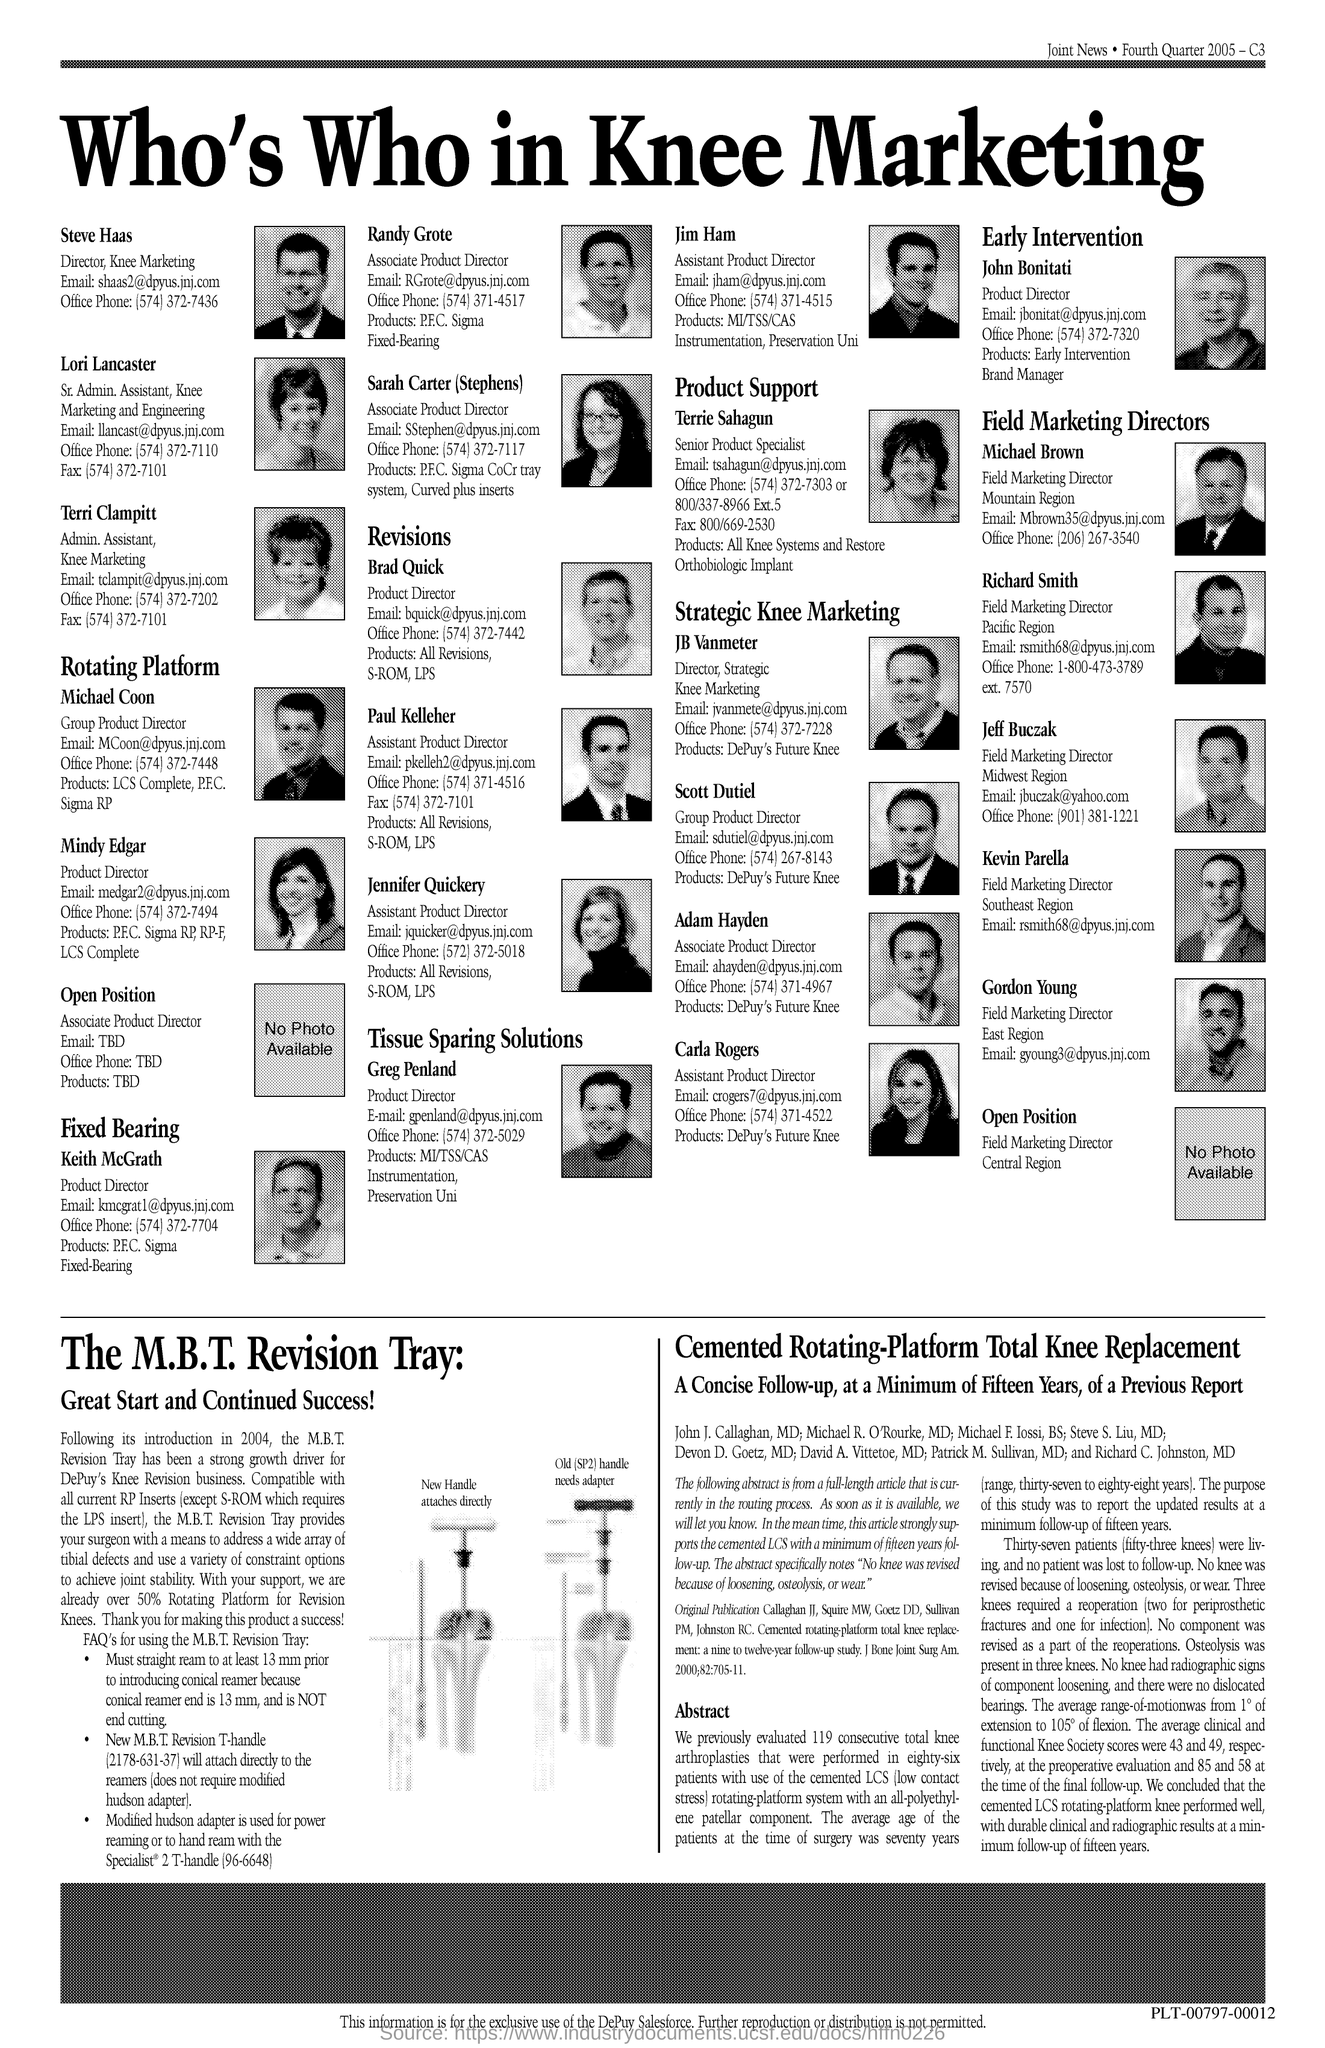What is the name of the Director in Knee Marketing?
Offer a terse response. Steve Haas. What is the name of the Admin.Assistant in Knee Marketing?
Provide a short and direct response. Terri Clampitt. What is the designation of Richard Smith?
Offer a very short reply. Field Marketing Director. 